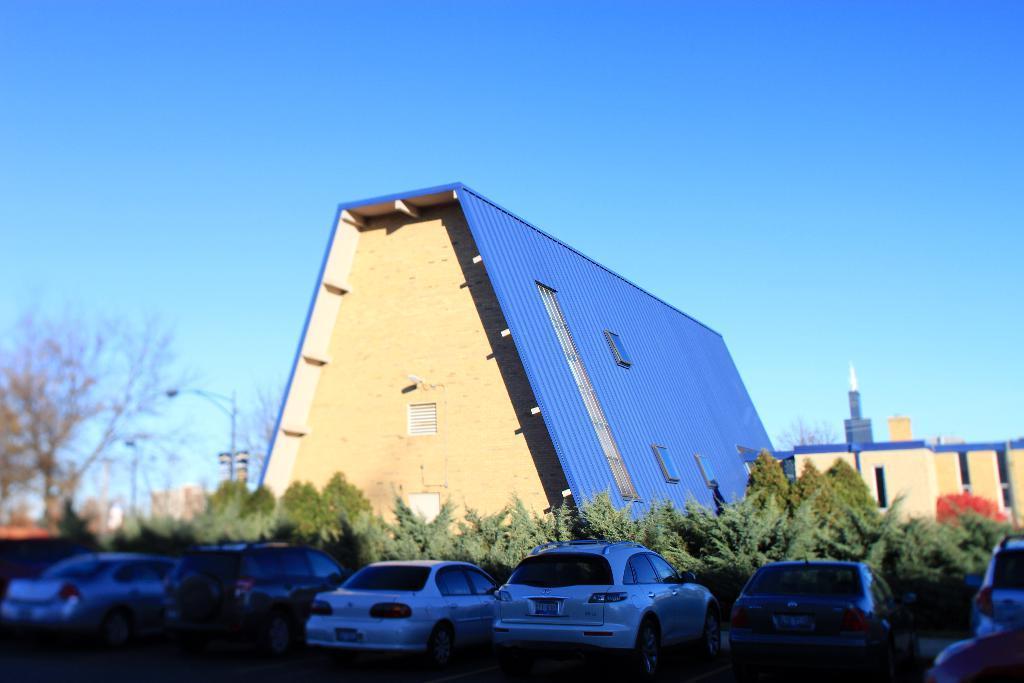Please provide a concise description of this image. In this image I can see the buildings, windows, trees, light poles and few vehicles. The sky is in blue and white color. 